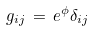Convert formula to latex. <formula><loc_0><loc_0><loc_500><loc_500>g _ { i j } \, = \, e ^ { \phi } \delta _ { i j }</formula> 